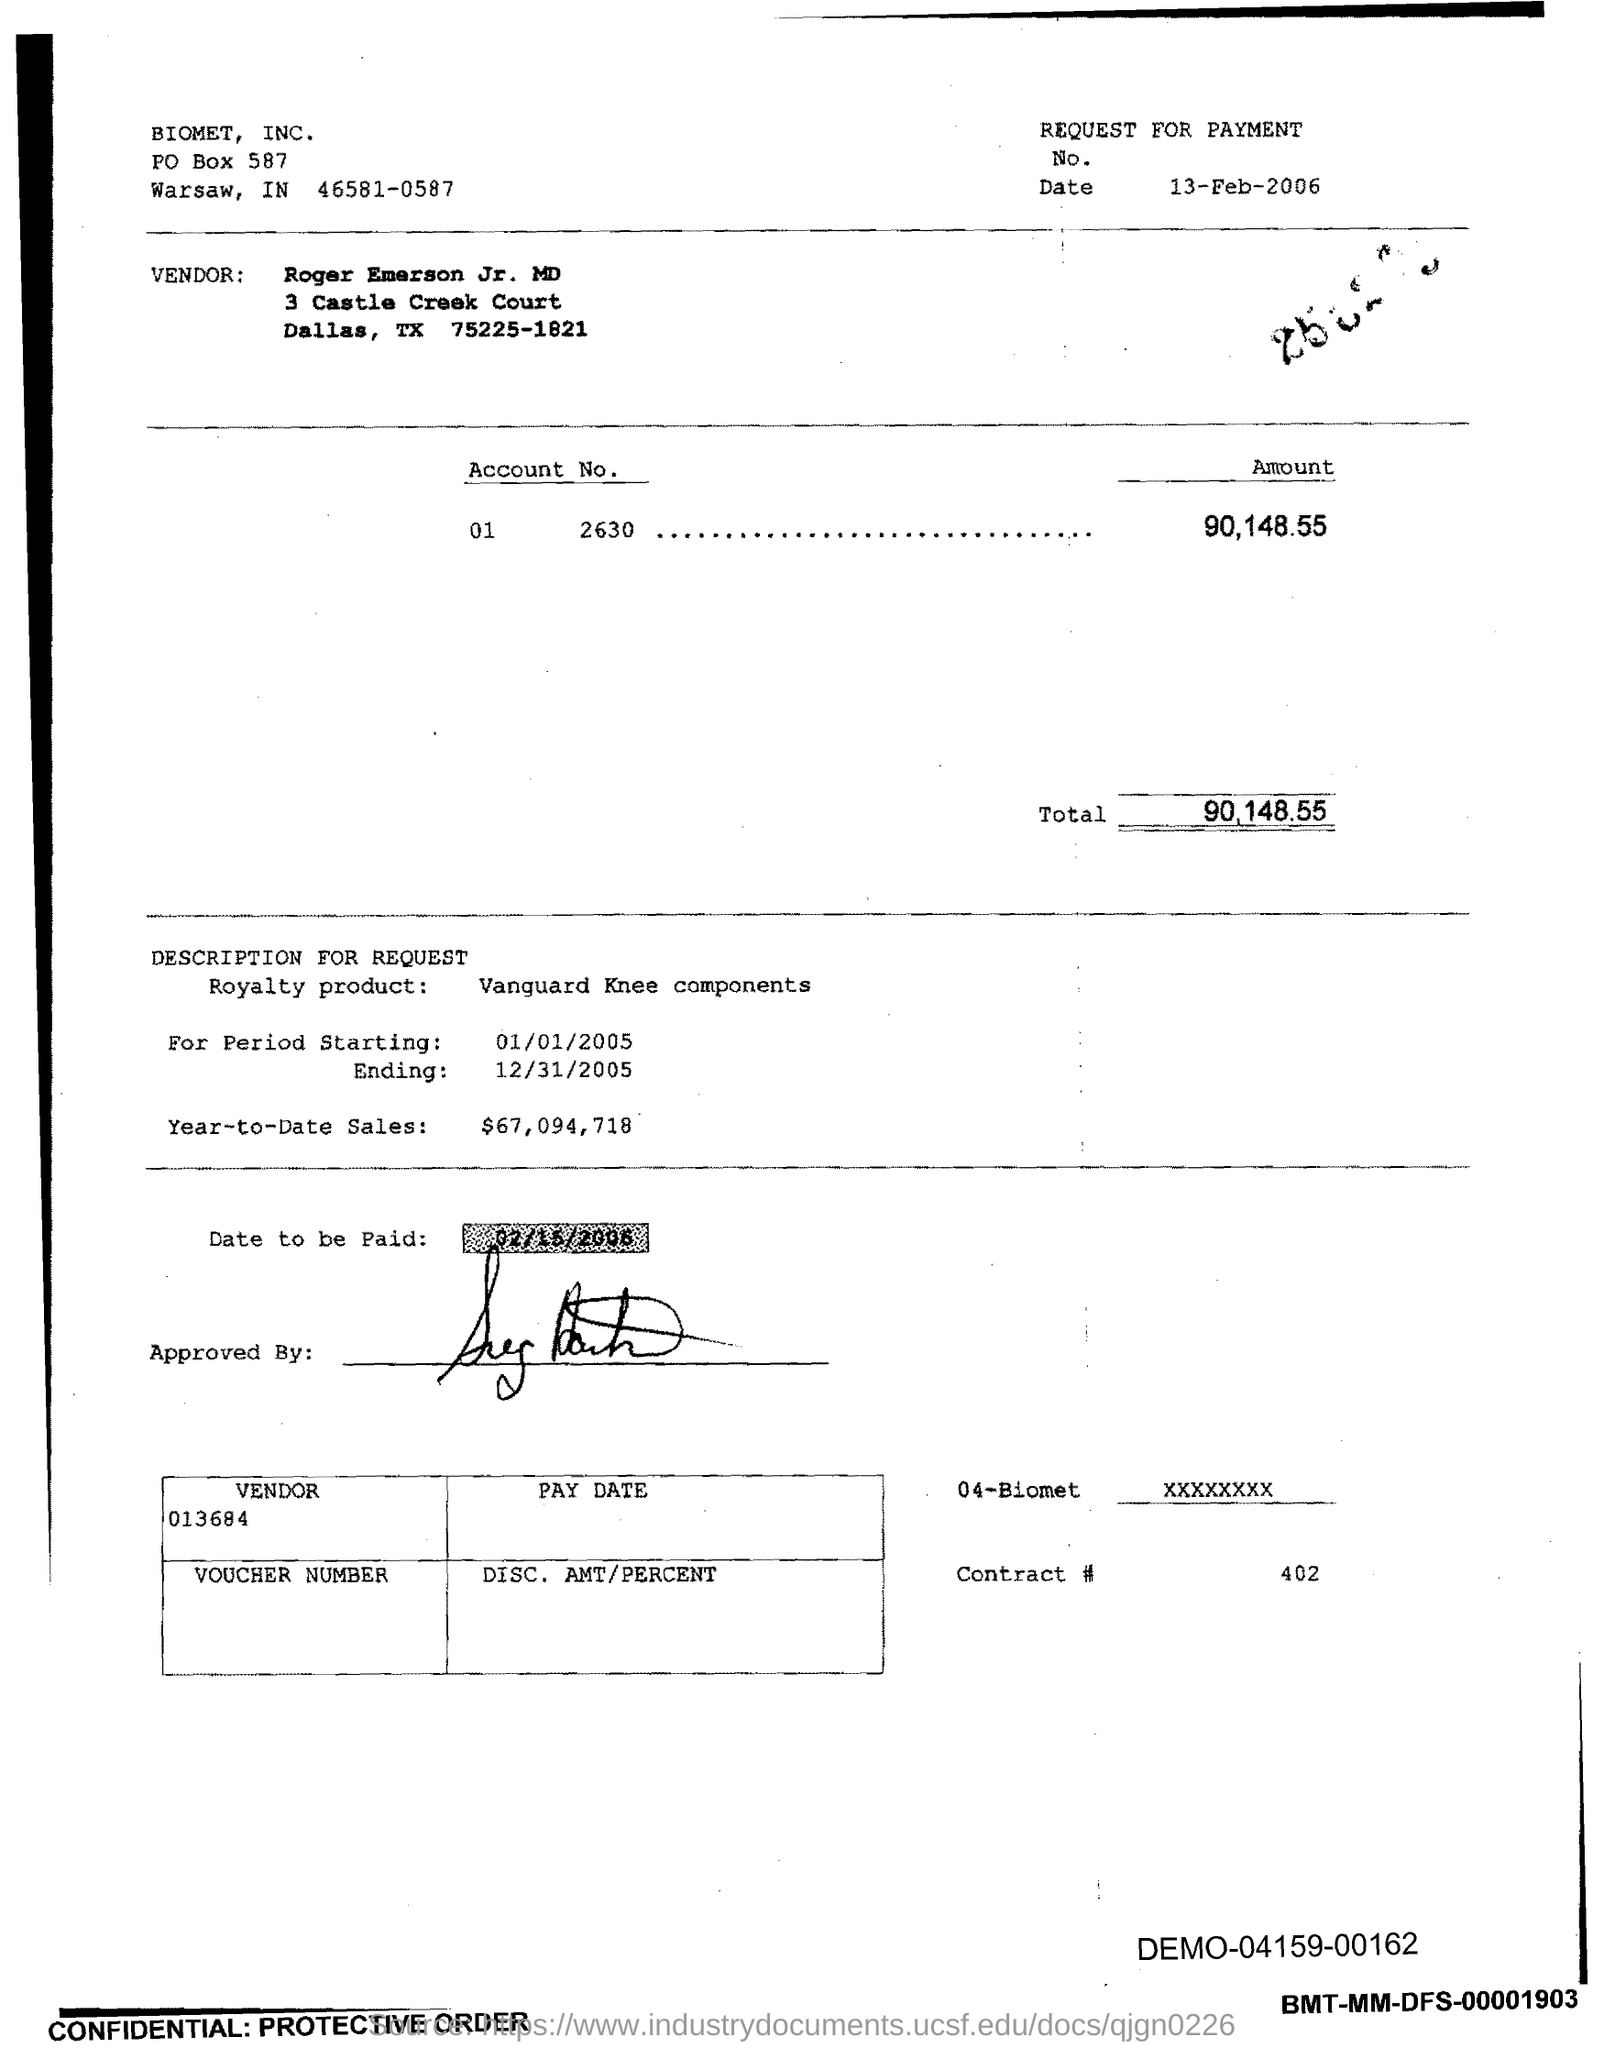Who is the vendor?
Offer a terse response. Roger emerson jr. MD. When was the request for payment raised?
Your answer should be very brief. 13-feb-2006. What is the vendor ID?
Ensure brevity in your answer.  013684. What is the contract number?
Ensure brevity in your answer.  402. 